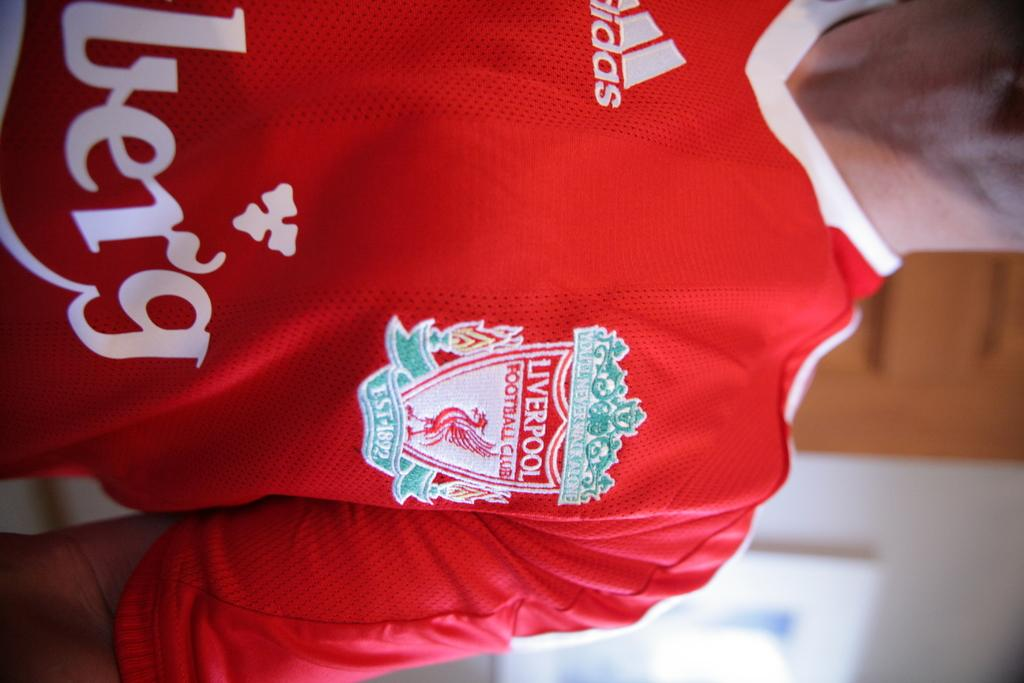<image>
Offer a succinct explanation of the picture presented. A person wearing a red liverpool jersey and its a man 